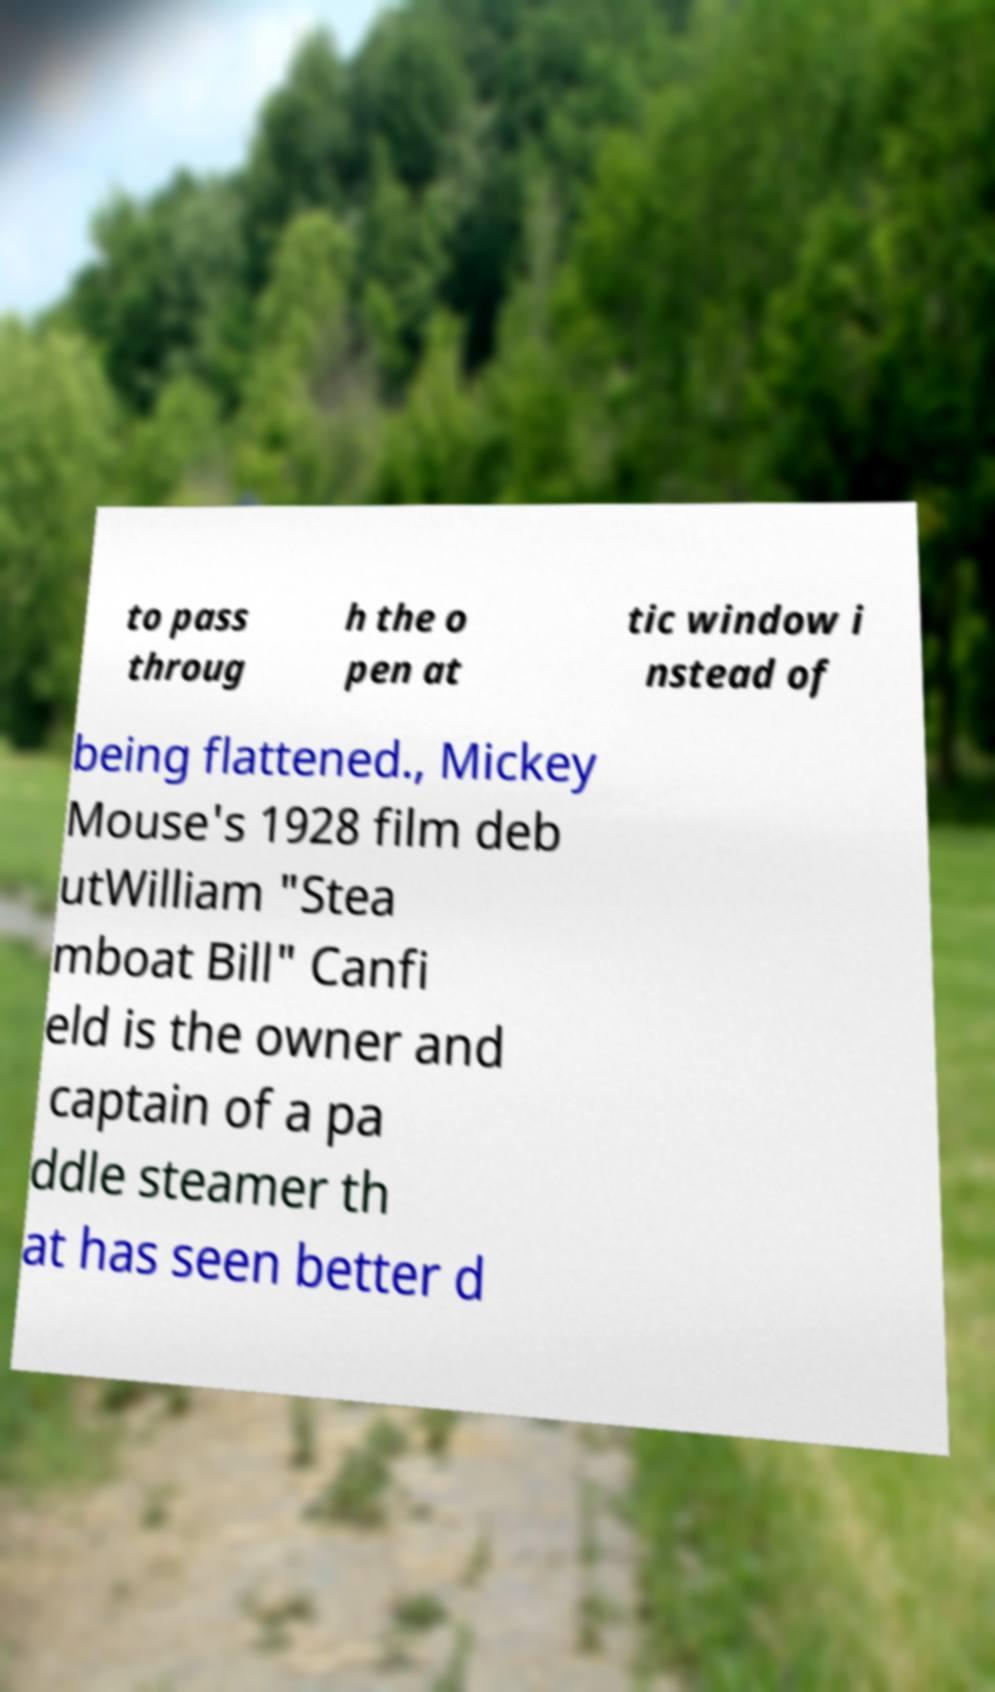Can you read and provide the text displayed in the image?This photo seems to have some interesting text. Can you extract and type it out for me? to pass throug h the o pen at tic window i nstead of being flattened., Mickey Mouse's 1928 film deb utWilliam "Stea mboat Bill" Canfi eld is the owner and captain of a pa ddle steamer th at has seen better d 